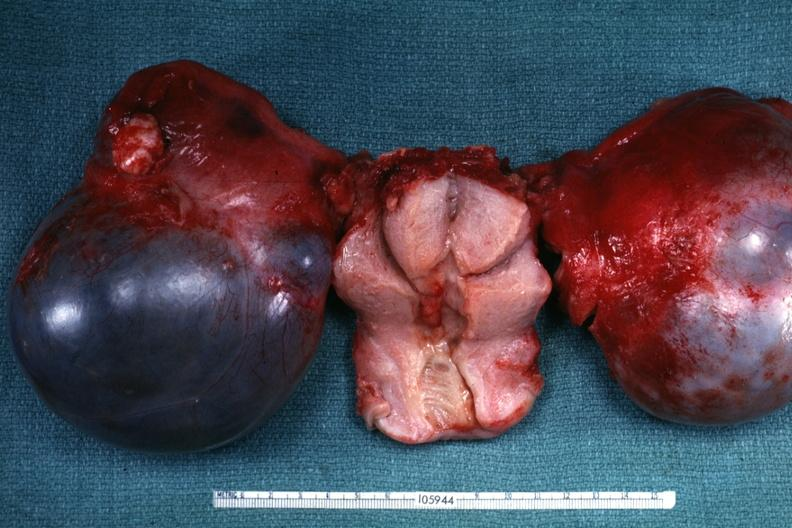s cytomegalovirus present?
Answer the question using a single word or phrase. No 